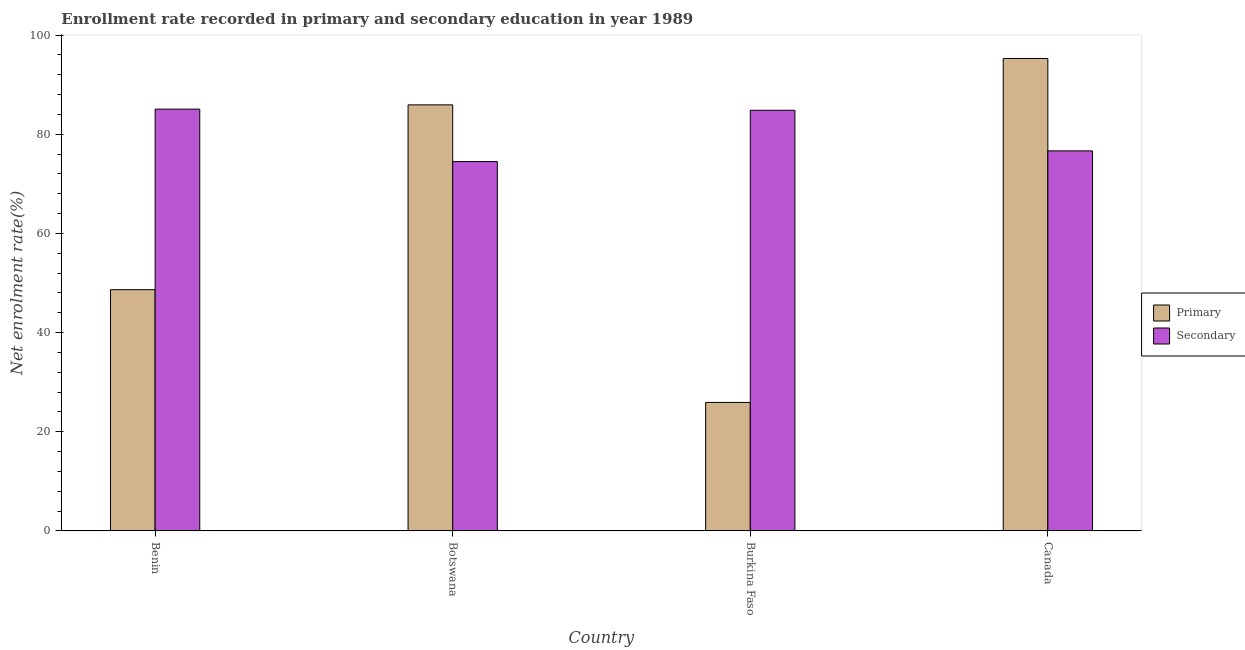How many different coloured bars are there?
Your response must be concise. 2. What is the label of the 2nd group of bars from the left?
Ensure brevity in your answer.  Botswana. In how many cases, is the number of bars for a given country not equal to the number of legend labels?
Ensure brevity in your answer.  0. What is the enrollment rate in primary education in Burkina Faso?
Make the answer very short. 25.91. Across all countries, what is the maximum enrollment rate in secondary education?
Ensure brevity in your answer.  85.06. Across all countries, what is the minimum enrollment rate in secondary education?
Make the answer very short. 74.49. In which country was the enrollment rate in primary education maximum?
Offer a terse response. Canada. In which country was the enrollment rate in primary education minimum?
Your answer should be very brief. Burkina Faso. What is the total enrollment rate in secondary education in the graph?
Your answer should be very brief. 321.03. What is the difference between the enrollment rate in secondary education in Botswana and that in Burkina Faso?
Provide a short and direct response. -10.34. What is the difference between the enrollment rate in secondary education in Canada and the enrollment rate in primary education in Botswana?
Your answer should be very brief. -9.28. What is the average enrollment rate in secondary education per country?
Offer a very short reply. 80.26. What is the difference between the enrollment rate in secondary education and enrollment rate in primary education in Benin?
Keep it short and to the point. 36.41. What is the ratio of the enrollment rate in primary education in Burkina Faso to that in Canada?
Your response must be concise. 0.27. Is the enrollment rate in primary education in Benin less than that in Burkina Faso?
Give a very brief answer. No. Is the difference between the enrollment rate in secondary education in Botswana and Canada greater than the difference between the enrollment rate in primary education in Botswana and Canada?
Keep it short and to the point. Yes. What is the difference between the highest and the second highest enrollment rate in secondary education?
Make the answer very short. 0.23. What is the difference between the highest and the lowest enrollment rate in primary education?
Your answer should be very brief. 69.36. What does the 2nd bar from the left in Canada represents?
Offer a terse response. Secondary. What does the 1st bar from the right in Burkina Faso represents?
Provide a succinct answer. Secondary. Are all the bars in the graph horizontal?
Provide a short and direct response. No. How many countries are there in the graph?
Offer a very short reply. 4. How are the legend labels stacked?
Provide a short and direct response. Vertical. What is the title of the graph?
Offer a terse response. Enrollment rate recorded in primary and secondary education in year 1989. What is the label or title of the X-axis?
Give a very brief answer. Country. What is the label or title of the Y-axis?
Offer a terse response. Net enrolment rate(%). What is the Net enrolment rate(%) of Primary in Benin?
Your answer should be very brief. 48.65. What is the Net enrolment rate(%) of Secondary in Benin?
Your answer should be very brief. 85.06. What is the Net enrolment rate(%) of Primary in Botswana?
Provide a succinct answer. 85.92. What is the Net enrolment rate(%) of Secondary in Botswana?
Ensure brevity in your answer.  74.49. What is the Net enrolment rate(%) in Primary in Burkina Faso?
Ensure brevity in your answer.  25.91. What is the Net enrolment rate(%) in Secondary in Burkina Faso?
Offer a very short reply. 84.83. What is the Net enrolment rate(%) of Primary in Canada?
Your answer should be very brief. 95.27. What is the Net enrolment rate(%) of Secondary in Canada?
Your response must be concise. 76.64. Across all countries, what is the maximum Net enrolment rate(%) of Primary?
Your response must be concise. 95.27. Across all countries, what is the maximum Net enrolment rate(%) of Secondary?
Provide a short and direct response. 85.06. Across all countries, what is the minimum Net enrolment rate(%) of Primary?
Provide a succinct answer. 25.91. Across all countries, what is the minimum Net enrolment rate(%) in Secondary?
Your answer should be compact. 74.49. What is the total Net enrolment rate(%) in Primary in the graph?
Offer a terse response. 255.77. What is the total Net enrolment rate(%) of Secondary in the graph?
Provide a short and direct response. 321.03. What is the difference between the Net enrolment rate(%) in Primary in Benin and that in Botswana?
Give a very brief answer. -37.27. What is the difference between the Net enrolment rate(%) of Secondary in Benin and that in Botswana?
Offer a very short reply. 10.57. What is the difference between the Net enrolment rate(%) of Primary in Benin and that in Burkina Faso?
Provide a short and direct response. 22.74. What is the difference between the Net enrolment rate(%) of Secondary in Benin and that in Burkina Faso?
Give a very brief answer. 0.23. What is the difference between the Net enrolment rate(%) in Primary in Benin and that in Canada?
Offer a terse response. -46.62. What is the difference between the Net enrolment rate(%) in Secondary in Benin and that in Canada?
Offer a very short reply. 8.42. What is the difference between the Net enrolment rate(%) of Primary in Botswana and that in Burkina Faso?
Make the answer very short. 60.01. What is the difference between the Net enrolment rate(%) of Secondary in Botswana and that in Burkina Faso?
Keep it short and to the point. -10.34. What is the difference between the Net enrolment rate(%) in Primary in Botswana and that in Canada?
Your answer should be very brief. -9.35. What is the difference between the Net enrolment rate(%) in Secondary in Botswana and that in Canada?
Make the answer very short. -2.15. What is the difference between the Net enrolment rate(%) of Primary in Burkina Faso and that in Canada?
Make the answer very short. -69.36. What is the difference between the Net enrolment rate(%) in Secondary in Burkina Faso and that in Canada?
Your answer should be very brief. 8.19. What is the difference between the Net enrolment rate(%) in Primary in Benin and the Net enrolment rate(%) in Secondary in Botswana?
Your answer should be compact. -25.84. What is the difference between the Net enrolment rate(%) in Primary in Benin and the Net enrolment rate(%) in Secondary in Burkina Faso?
Give a very brief answer. -36.18. What is the difference between the Net enrolment rate(%) of Primary in Benin and the Net enrolment rate(%) of Secondary in Canada?
Your answer should be very brief. -27.99. What is the difference between the Net enrolment rate(%) of Primary in Botswana and the Net enrolment rate(%) of Secondary in Burkina Faso?
Your answer should be very brief. 1.09. What is the difference between the Net enrolment rate(%) of Primary in Botswana and the Net enrolment rate(%) of Secondary in Canada?
Give a very brief answer. 9.28. What is the difference between the Net enrolment rate(%) in Primary in Burkina Faso and the Net enrolment rate(%) in Secondary in Canada?
Provide a succinct answer. -50.73. What is the average Net enrolment rate(%) in Primary per country?
Your answer should be very brief. 63.94. What is the average Net enrolment rate(%) in Secondary per country?
Ensure brevity in your answer.  80.26. What is the difference between the Net enrolment rate(%) of Primary and Net enrolment rate(%) of Secondary in Benin?
Offer a very short reply. -36.41. What is the difference between the Net enrolment rate(%) of Primary and Net enrolment rate(%) of Secondary in Botswana?
Your response must be concise. 11.43. What is the difference between the Net enrolment rate(%) of Primary and Net enrolment rate(%) of Secondary in Burkina Faso?
Offer a terse response. -58.92. What is the difference between the Net enrolment rate(%) in Primary and Net enrolment rate(%) in Secondary in Canada?
Keep it short and to the point. 18.63. What is the ratio of the Net enrolment rate(%) in Primary in Benin to that in Botswana?
Your answer should be very brief. 0.57. What is the ratio of the Net enrolment rate(%) in Secondary in Benin to that in Botswana?
Ensure brevity in your answer.  1.14. What is the ratio of the Net enrolment rate(%) in Primary in Benin to that in Burkina Faso?
Your response must be concise. 1.88. What is the ratio of the Net enrolment rate(%) of Primary in Benin to that in Canada?
Your response must be concise. 0.51. What is the ratio of the Net enrolment rate(%) of Secondary in Benin to that in Canada?
Keep it short and to the point. 1.11. What is the ratio of the Net enrolment rate(%) of Primary in Botswana to that in Burkina Faso?
Offer a very short reply. 3.32. What is the ratio of the Net enrolment rate(%) in Secondary in Botswana to that in Burkina Faso?
Provide a short and direct response. 0.88. What is the ratio of the Net enrolment rate(%) of Primary in Botswana to that in Canada?
Offer a terse response. 0.9. What is the ratio of the Net enrolment rate(%) in Secondary in Botswana to that in Canada?
Make the answer very short. 0.97. What is the ratio of the Net enrolment rate(%) in Primary in Burkina Faso to that in Canada?
Offer a very short reply. 0.27. What is the ratio of the Net enrolment rate(%) in Secondary in Burkina Faso to that in Canada?
Provide a short and direct response. 1.11. What is the difference between the highest and the second highest Net enrolment rate(%) in Primary?
Keep it short and to the point. 9.35. What is the difference between the highest and the second highest Net enrolment rate(%) of Secondary?
Give a very brief answer. 0.23. What is the difference between the highest and the lowest Net enrolment rate(%) in Primary?
Keep it short and to the point. 69.36. What is the difference between the highest and the lowest Net enrolment rate(%) of Secondary?
Keep it short and to the point. 10.57. 